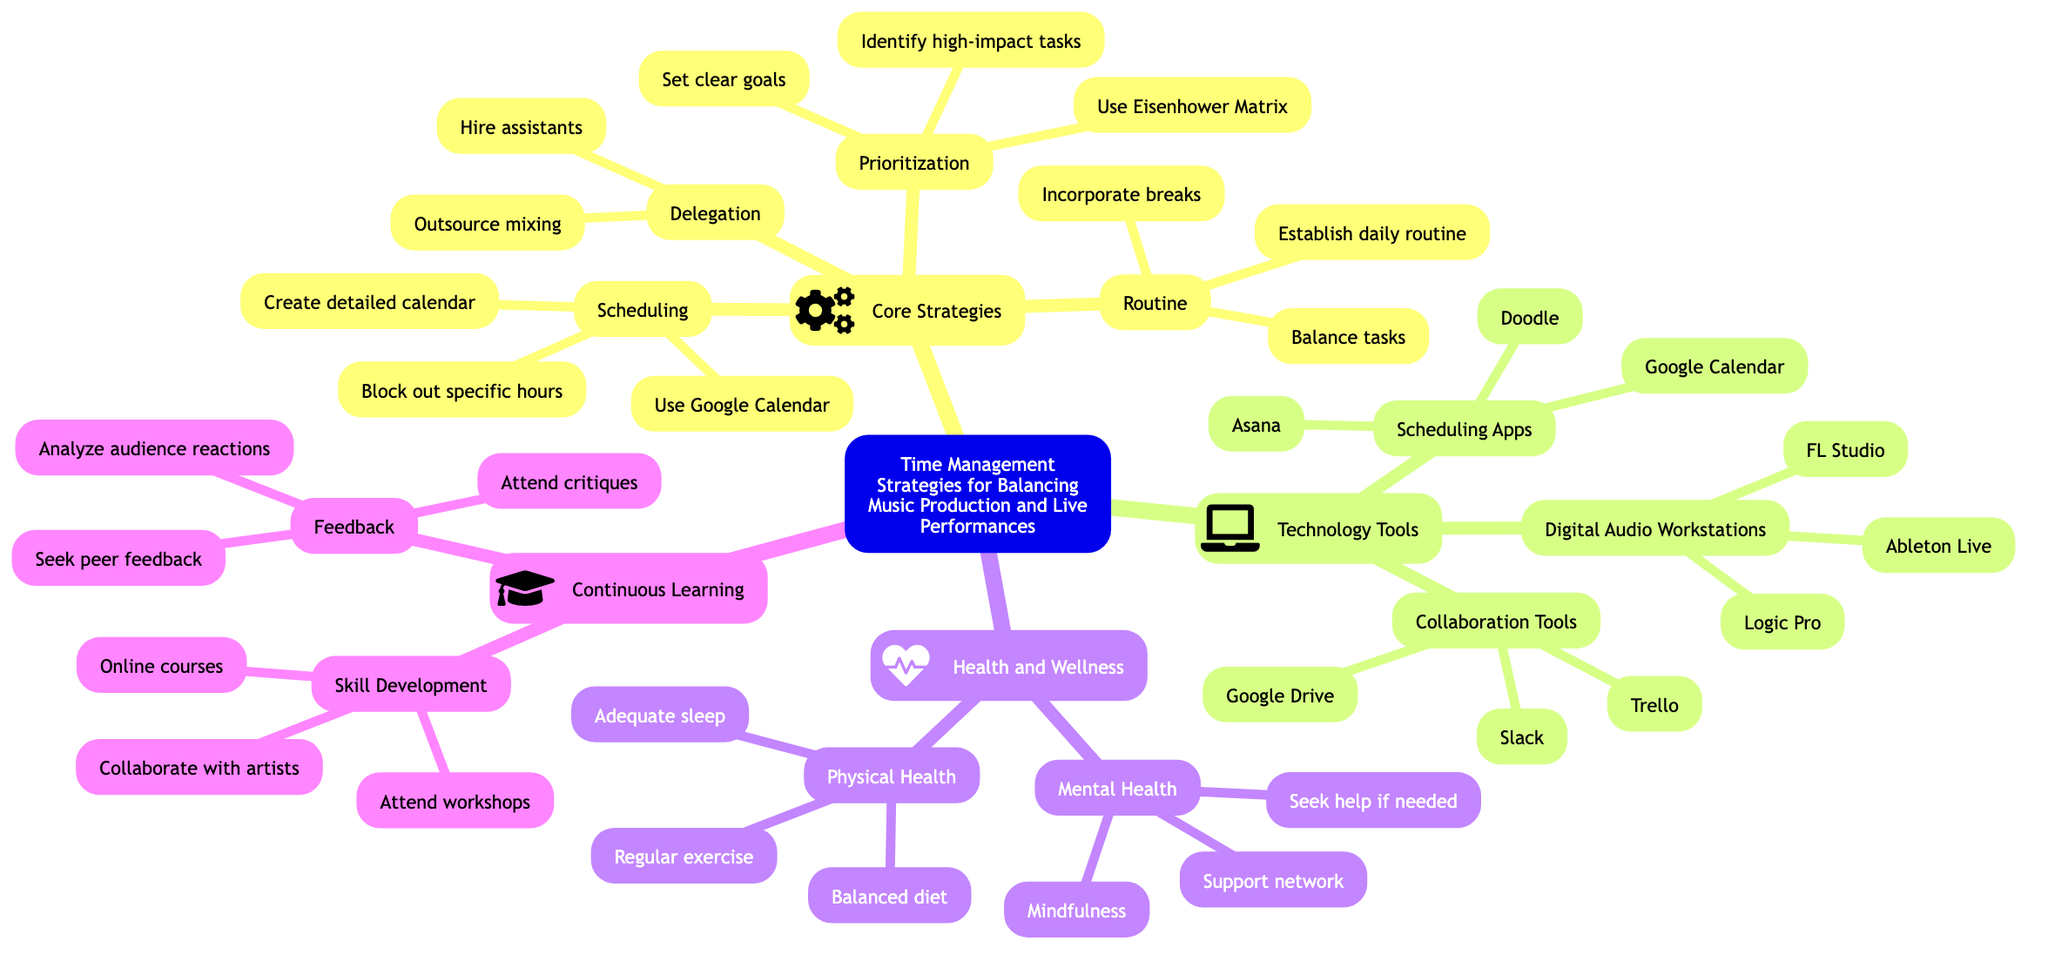What is the primary focus of the concept map? The concept map is centered around "Time Management Strategies for Balancing Music Production and Live Performances," which is clearly indicated at the root node of the diagram.
Answer: Time Management Strategies for Balancing Music Production and Live Performances How many core strategies are listed in the diagram? There are four core strategies mentioned: Delegation, Prioritization, Scheduling, and Routine. Counting these nodes verifies there are four core strategies.
Answer: 4 What are the three examples of Digital Audio Workstations listed? The concept map lists three Digital Audio Workstations: Ableton Live, FL Studio, and Logic Pro. Each of these is a child node under the "Digital Audio Workstations" category.
Answer: Ableton Live, FL Studio, Logic Pro What is the main purpose of the "Health and Wellness" section? The "Health and Wellness" section aims to cover the aspects of both Physical Health and Mental Health, promoting a holistic approach to time management and productivity. This is indicated by it being a top-level node that includes two sub-nodes.
Answer: To promote overall well-being Which tool is specifically used for communication according to the diagram? The diagram identifies Slack as the tool designated for communication, which is listed under "Collaboration Tools."
Answer: Slack How does "Prioritization" relate to "Scheduling"? "Prioritization" emphasizes setting clear goals and identifying high-impact tasks, which should inform and guide what gets scheduled in "Scheduling," making it a fundamental step before creating a calendar. This relationship shows how careful prioritization leads to effective scheduling.
Answer: Prioritization informs Scheduling What strategies are recommended for "Mental Health"? The recommended strategies under "Mental Health" are practicing mindfulness or meditation, seeking professional help if needed, and maintaining a support network, which can be found as sub-nodes under the main "Mental Health" node.
Answer: Mindfulness, Seek help if needed, Support network Which section includes skill development strategies? The "Continuous Learning" section encompasses skill development strategies which includes attending workshops, online courses, and collaborating with other artists, highlighting the importance of lifelong learning in music production and performance.
Answer: Continuous Learning 